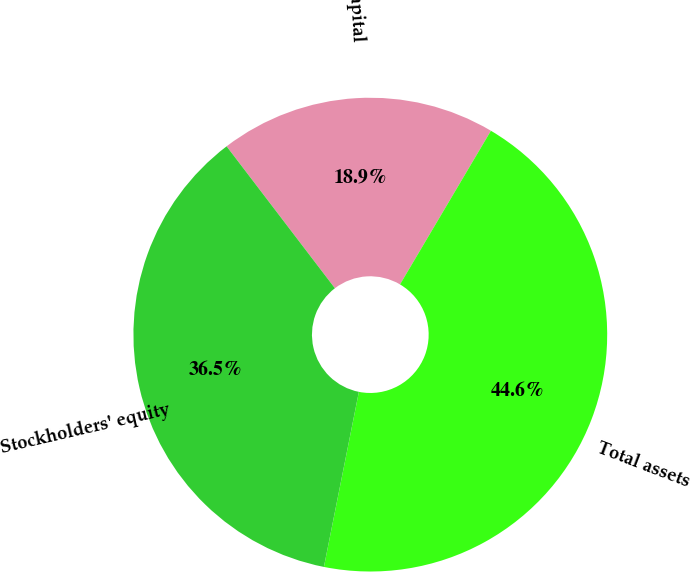<chart> <loc_0><loc_0><loc_500><loc_500><pie_chart><fcel>Working capital<fcel>Total assets<fcel>Stockholders' equity<nl><fcel>18.88%<fcel>44.64%<fcel>36.49%<nl></chart> 